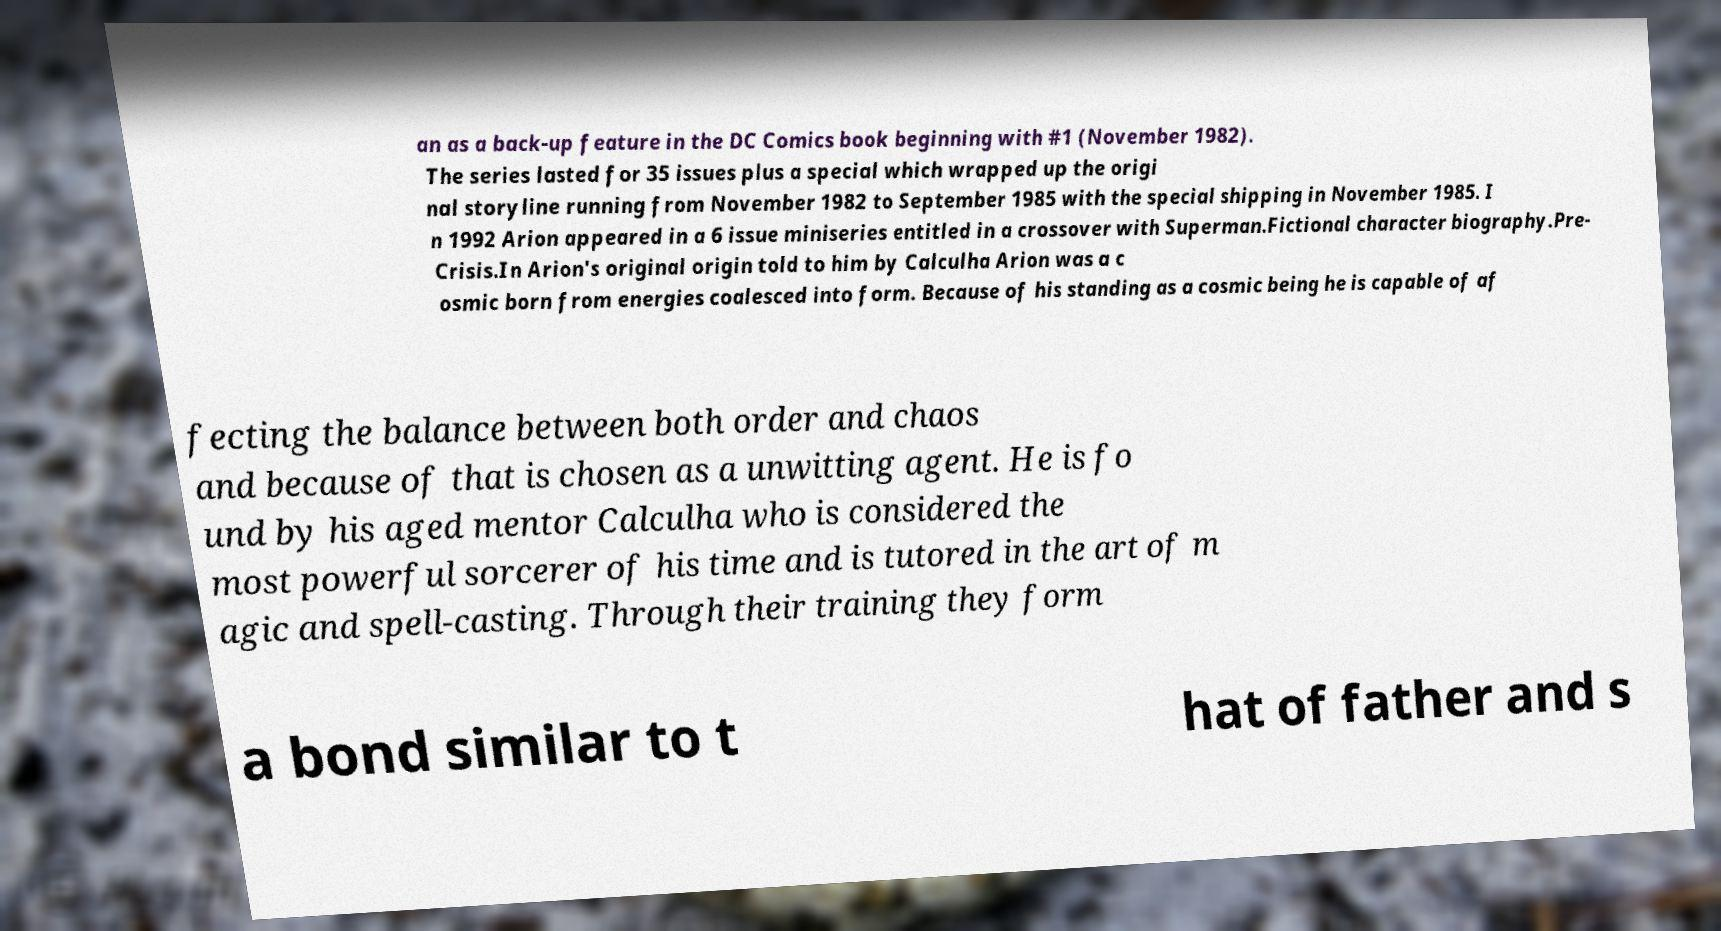Please read and relay the text visible in this image. What does it say? an as a back-up feature in the DC Comics book beginning with #1 (November 1982). The series lasted for 35 issues plus a special which wrapped up the origi nal storyline running from November 1982 to September 1985 with the special shipping in November 1985. I n 1992 Arion appeared in a 6 issue miniseries entitled in a crossover with Superman.Fictional character biography.Pre- Crisis.In Arion's original origin told to him by Calculha Arion was a c osmic born from energies coalesced into form. Because of his standing as a cosmic being he is capable of af fecting the balance between both order and chaos and because of that is chosen as a unwitting agent. He is fo und by his aged mentor Calculha who is considered the most powerful sorcerer of his time and is tutored in the art of m agic and spell-casting. Through their training they form a bond similar to t hat of father and s 